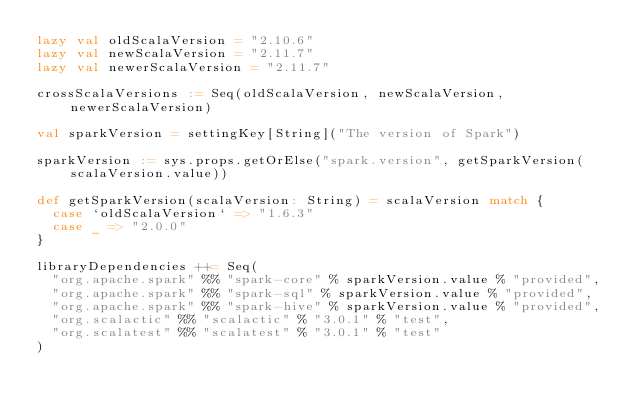Convert code to text. <code><loc_0><loc_0><loc_500><loc_500><_Scala_>lazy val oldScalaVersion = "2.10.6"
lazy val newScalaVersion = "2.11.7"
lazy val newerScalaVersion = "2.11.7"

crossScalaVersions := Seq(oldScalaVersion, newScalaVersion, newerScalaVersion)

val sparkVersion = settingKey[String]("The version of Spark")

sparkVersion := sys.props.getOrElse("spark.version", getSparkVersion(scalaVersion.value))

def getSparkVersion(scalaVersion: String) = scalaVersion match {
  case `oldScalaVersion` => "1.6.3"
  case _ => "2.0.0"
}

libraryDependencies ++= Seq(
  "org.apache.spark" %% "spark-core" % sparkVersion.value % "provided",
  "org.apache.spark" %% "spark-sql" % sparkVersion.value % "provided",
  "org.apache.spark" %% "spark-hive" % sparkVersion.value % "provided",
  "org.scalactic" %% "scalactic" % "3.0.1" % "test",
  "org.scalatest" %% "scalatest" % "3.0.1" % "test"
)
</code> 